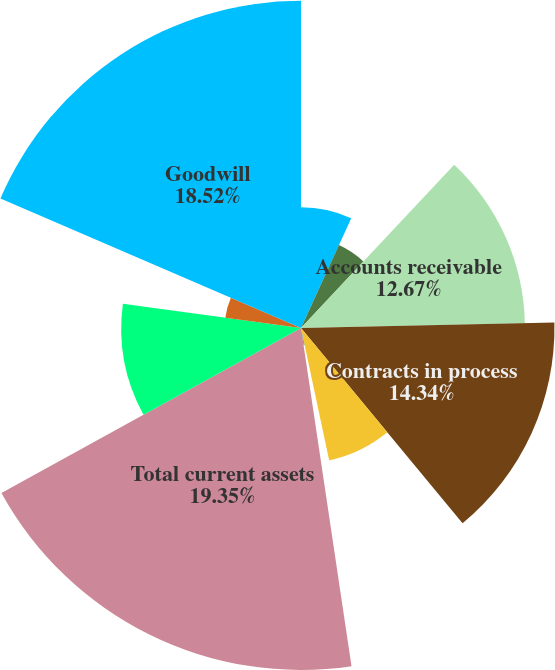Convert chart. <chart><loc_0><loc_0><loc_500><loc_500><pie_chart><fcel>(Dollars in millions)<fcel>Cash and equivalents<fcel>Accounts receivable<fcel>Contracts in process<fcel>Inventories<fcel>Other current assets<fcel>Total current assets<fcel>Property plant and equipment<fcel>Intangible assets net<fcel>Goodwill<nl><fcel>6.83%<fcel>5.16%<fcel>12.67%<fcel>14.34%<fcel>7.66%<fcel>0.98%<fcel>19.35%<fcel>10.17%<fcel>4.32%<fcel>18.52%<nl></chart> 